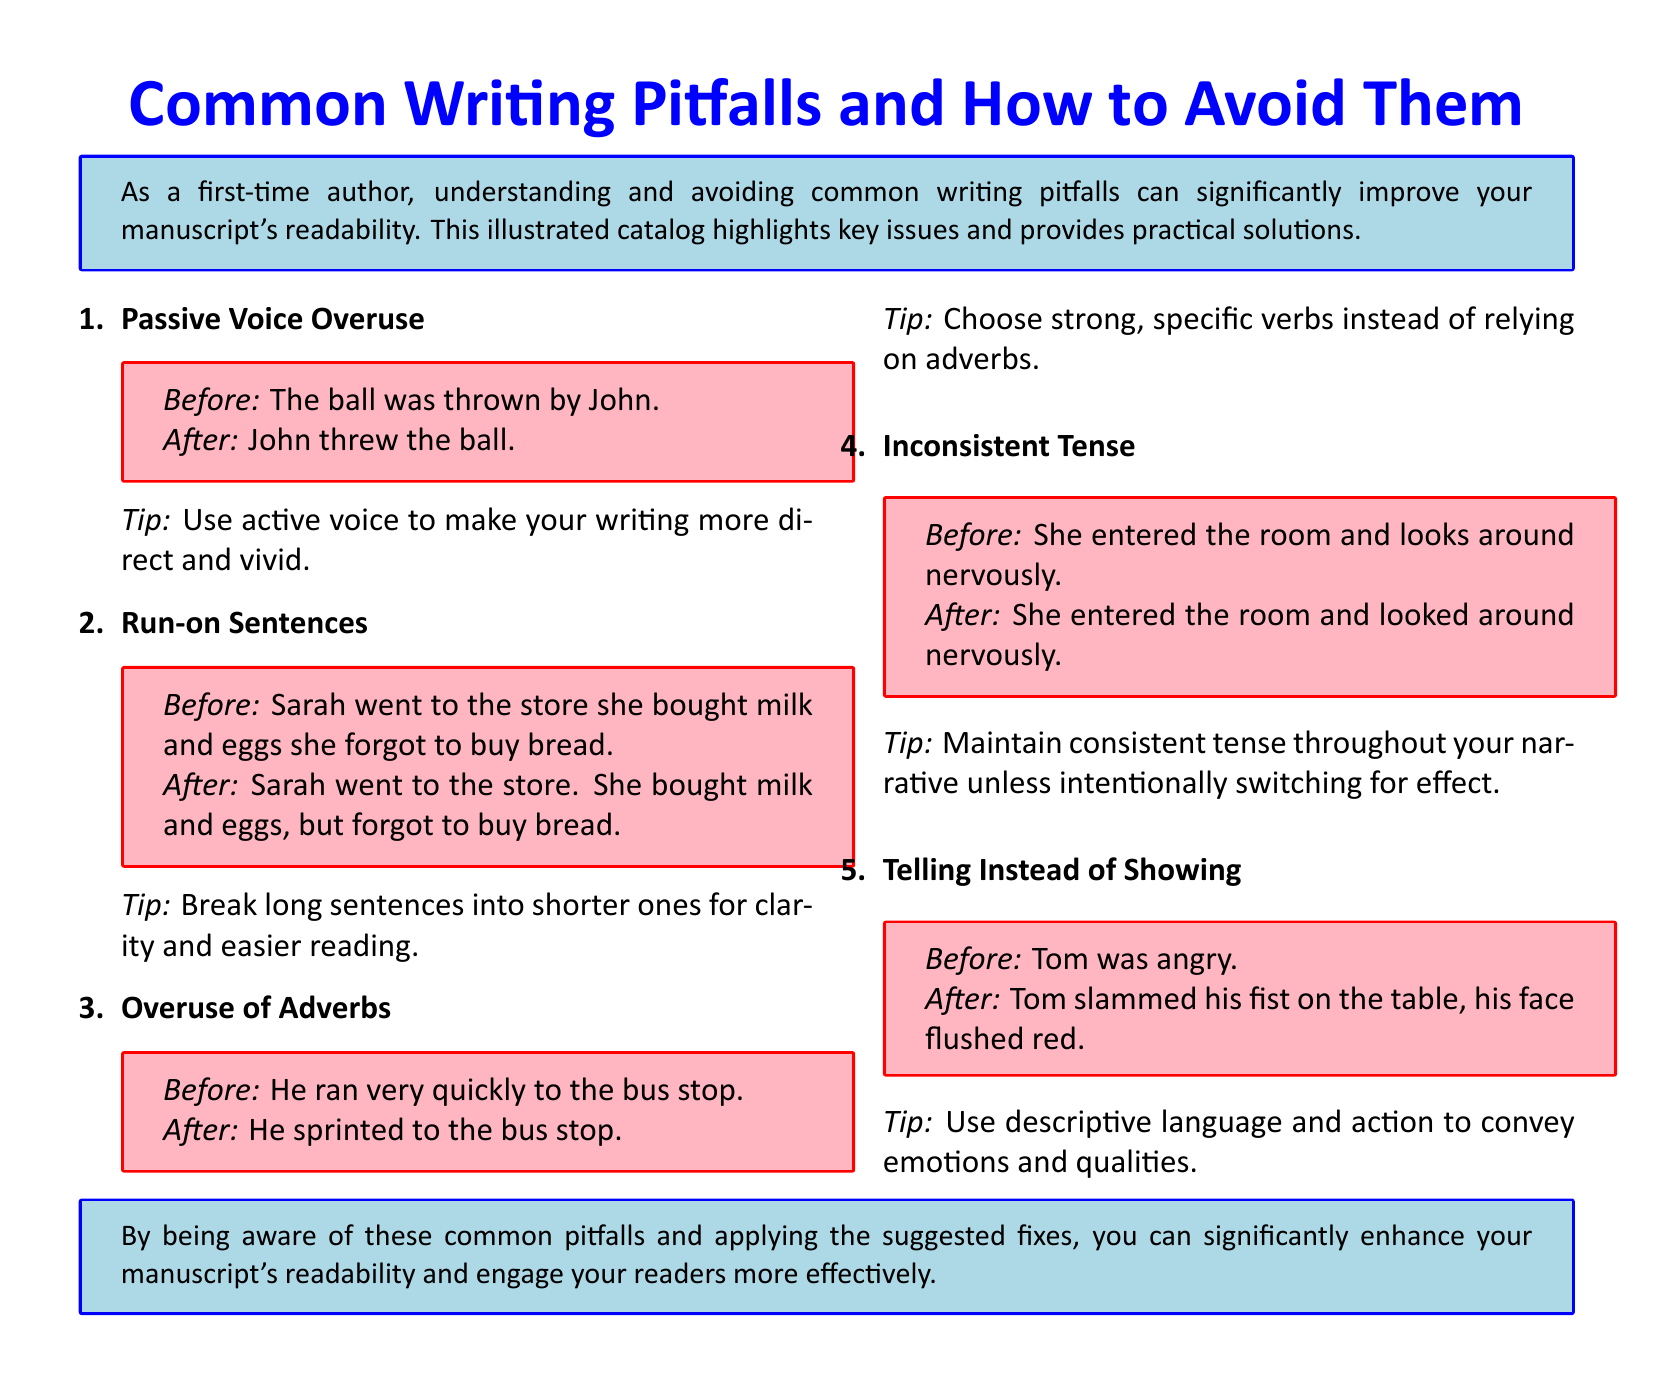What is the title of the document? The title is prominently displayed at the top of the document.
Answer: Common Writing Pitfalls and How to Avoid Them How many writing pitfalls are listed in the document? The document enumerates the issues in a list format.
Answer: Five What color is the background of the tips box? The background color of the tips boxes is specified in the document.
Answer: Light pink What is the suggested correction for passive voice overuse? The document includes a before-and-after example for each writing pitfall.
Answer: Use active voice to make your writing more direct and vivid What specific example is used for showing instead of telling? The document provides examples of revised sentences for clarity.
Answer: Tom slammed his fist on the table, his face flushed red What font is used in the document? The document specifies the main font at the start.
Answer: Calibri Which writing issue is related to verb usage? The document addresses multiple issues with examples.
Answer: Overuse of adverbs What is one tip for correcting run-on sentences? The document includes tips for addressing each writing pitfall.
Answer: Break long sentences into shorter ones for clarity and easier reading 